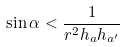<formula> <loc_0><loc_0><loc_500><loc_500>\sin \alpha < \frac { 1 } { r ^ { 2 } h _ { a } h _ { a ^ { \prime } } }</formula> 